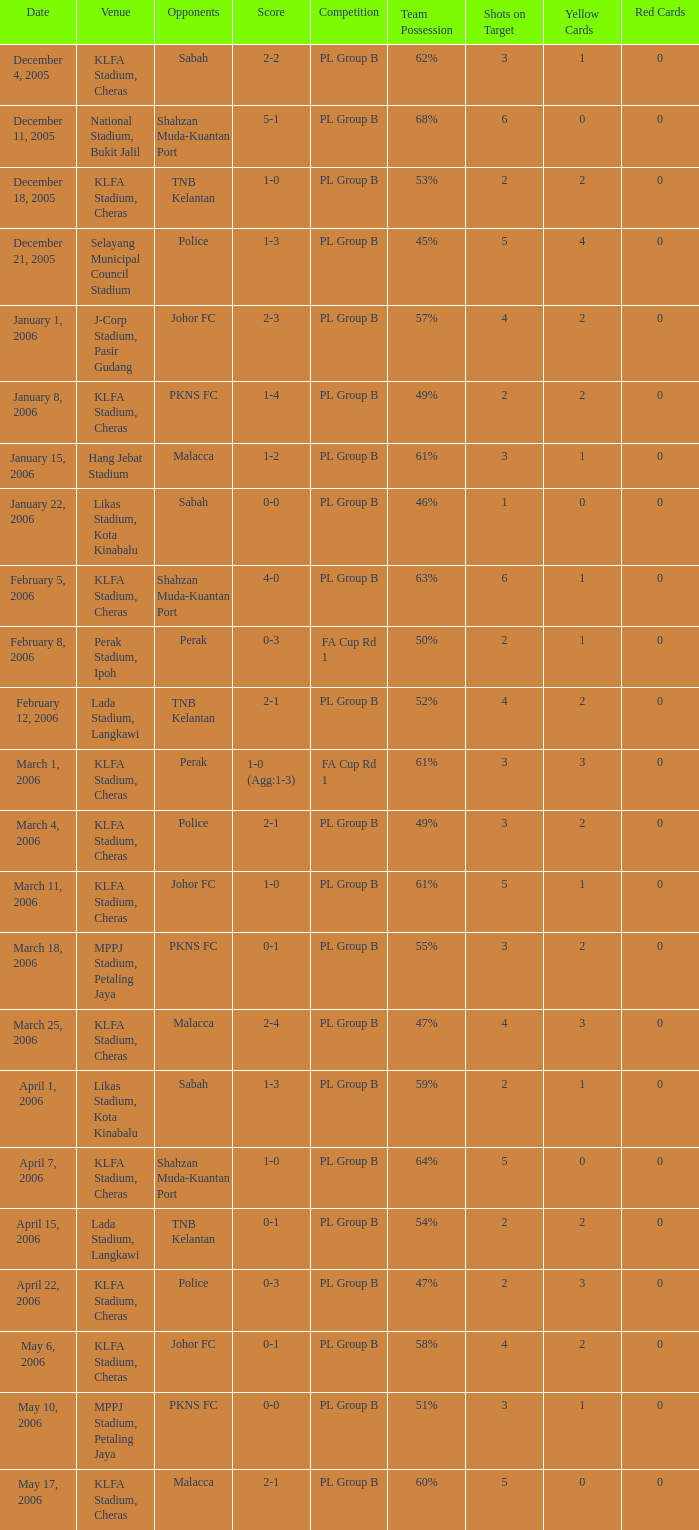Which Date has a Competition of pl group b, and Opponents of police, and a Venue of selayang municipal council stadium? December 21, 2005. Help me parse the entirety of this table. {'header': ['Date', 'Venue', 'Opponents', 'Score', 'Competition', 'Team Possession', 'Shots on Target', 'Yellow Cards', 'Red Cards'], 'rows': [['December 4, 2005', 'KLFA Stadium, Cheras', 'Sabah', '2-2', 'PL Group B', '62%', '3', '1', '0'], ['December 11, 2005', 'National Stadium, Bukit Jalil', 'Shahzan Muda-Kuantan Port', '5-1', 'PL Group B', '68%', '6', '0', '0'], ['December 18, 2005', 'KLFA Stadium, Cheras', 'TNB Kelantan', '1-0', 'PL Group B', '53%', '2', '2', '0'], ['December 21, 2005', 'Selayang Municipal Council Stadium', 'Police', '1-3', 'PL Group B', '45%', '5', '4', '0'], ['January 1, 2006', 'J-Corp Stadium, Pasir Gudang', 'Johor FC', '2-3', 'PL Group B', '57%', '4', '2', '0'], ['January 8, 2006', 'KLFA Stadium, Cheras', 'PKNS FC', '1-4', 'PL Group B', '49%', '2', '2', '0'], ['January 15, 2006', 'Hang Jebat Stadium', 'Malacca', '1-2', 'PL Group B', '61%', '3', '1', '0'], ['January 22, 2006', 'Likas Stadium, Kota Kinabalu', 'Sabah', '0-0', 'PL Group B', '46%', '1', '0', '0'], ['February 5, 2006', 'KLFA Stadium, Cheras', 'Shahzan Muda-Kuantan Port', '4-0', 'PL Group B', '63%', '6', '1', '0'], ['February 8, 2006', 'Perak Stadium, Ipoh', 'Perak', '0-3', 'FA Cup Rd 1', '50%', '2', '1', '0'], ['February 12, 2006', 'Lada Stadium, Langkawi', 'TNB Kelantan', '2-1', 'PL Group B', '52%', '4', '2', '0'], ['March 1, 2006', 'KLFA Stadium, Cheras', 'Perak', '1-0 (Agg:1-3)', 'FA Cup Rd 1', '61%', '3', '3', '0'], ['March 4, 2006', 'KLFA Stadium, Cheras', 'Police', '2-1', 'PL Group B', '49%', '3', '2', '0'], ['March 11, 2006', 'KLFA Stadium, Cheras', 'Johor FC', '1-0', 'PL Group B', '61%', '5', '1', '0'], ['March 18, 2006', 'MPPJ Stadium, Petaling Jaya', 'PKNS FC', '0-1', 'PL Group B', '55%', '3', '2', '0'], ['March 25, 2006', 'KLFA Stadium, Cheras', 'Malacca', '2-4', 'PL Group B', '47%', '4', '3', '0'], ['April 1, 2006', 'Likas Stadium, Kota Kinabalu', 'Sabah', '1-3', 'PL Group B', '59%', '2', '1', '0'], ['April 7, 2006', 'KLFA Stadium, Cheras', 'Shahzan Muda-Kuantan Port', '1-0', 'PL Group B', '64%', '5', '0', '0'], ['April 15, 2006', 'Lada Stadium, Langkawi', 'TNB Kelantan', '0-1', 'PL Group B', '54%', '2', '2', '0'], ['April 22, 2006', 'KLFA Stadium, Cheras', 'Police', '0-3', 'PL Group B', '47%', '2', '3', '0'], ['May 6, 2006', 'KLFA Stadium, Cheras', 'Johor FC', '0-1', 'PL Group B', '58%', '4', '2', '0'], ['May 10, 2006', 'MPPJ Stadium, Petaling Jaya', 'PKNS FC', '0-0', 'PL Group B', '51%', '3', '1', '0'], ['May 17, 2006', 'KLFA Stadium, Cheras', 'Malacca', '2-1', 'PL Group B', '60%', '5', '0', '0']]} 